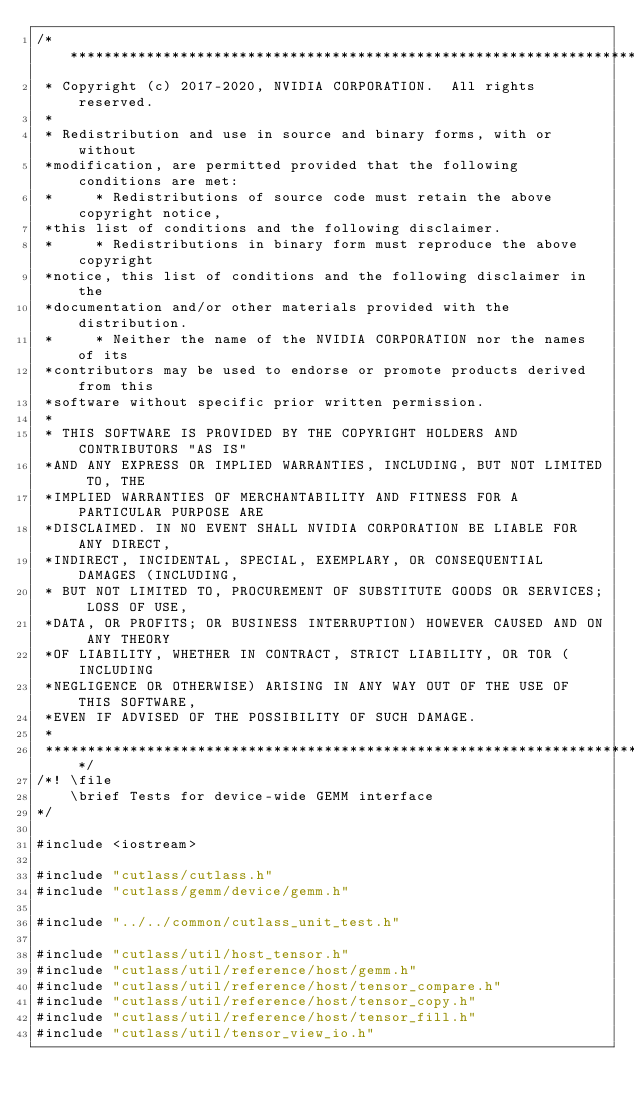Convert code to text. <code><loc_0><loc_0><loc_500><loc_500><_Cuda_>/***************************************************************************************************
 * Copyright (c) 2017-2020, NVIDIA CORPORATION.  All rights reserved.
 *
 * Redistribution and use in source and binary forms, with or without
 *modification, are permitted provided that the following conditions are met:
 *     * Redistributions of source code must retain the above copyright notice,
 *this list of conditions and the following disclaimer.
 *     * Redistributions in binary form must reproduce the above copyright
 *notice, this list of conditions and the following disclaimer in the
 *documentation and/or other materials provided with the distribution.
 *     * Neither the name of the NVIDIA CORPORATION nor the names of its
 *contributors may be used to endorse or promote products derived from this
 *software without specific prior written permission.
 *
 * THIS SOFTWARE IS PROVIDED BY THE COPYRIGHT HOLDERS AND CONTRIBUTORS "AS IS"
 *AND ANY EXPRESS OR IMPLIED WARRANTIES, INCLUDING, BUT NOT LIMITED TO, THE
 *IMPLIED WARRANTIES OF MERCHANTABILITY AND FITNESS FOR A PARTICULAR PURPOSE ARE
 *DISCLAIMED. IN NO EVENT SHALL NVIDIA CORPORATION BE LIABLE FOR ANY DIRECT,
 *INDIRECT, INCIDENTAL, SPECIAL, EXEMPLARY, OR CONSEQUENTIAL DAMAGES (INCLUDING,
 * BUT NOT LIMITED TO, PROCUREMENT OF SUBSTITUTE GOODS OR SERVICES; LOSS OF USE,
 *DATA, OR PROFITS; OR BUSINESS INTERRUPTION) HOWEVER CAUSED AND ON ANY THEORY
 *OF LIABILITY, WHETHER IN CONTRACT, STRICT LIABILITY, OR TOR (INCLUDING
 *NEGLIGENCE OR OTHERWISE) ARISING IN ANY WAY OUT OF THE USE OF THIS SOFTWARE,
 *EVEN IF ADVISED OF THE POSSIBILITY OF SUCH DAMAGE.
 *
 **************************************************************************************************/
/*! \file
    \brief Tests for device-wide GEMM interface
*/

#include <iostream>

#include "cutlass/cutlass.h"
#include "cutlass/gemm/device/gemm.h"

#include "../../common/cutlass_unit_test.h"

#include "cutlass/util/host_tensor.h"
#include "cutlass/util/reference/host/gemm.h"
#include "cutlass/util/reference/host/tensor_compare.h"
#include "cutlass/util/reference/host/tensor_copy.h"
#include "cutlass/util/reference/host/tensor_fill.h"
#include "cutlass/util/tensor_view_io.h"
</code> 